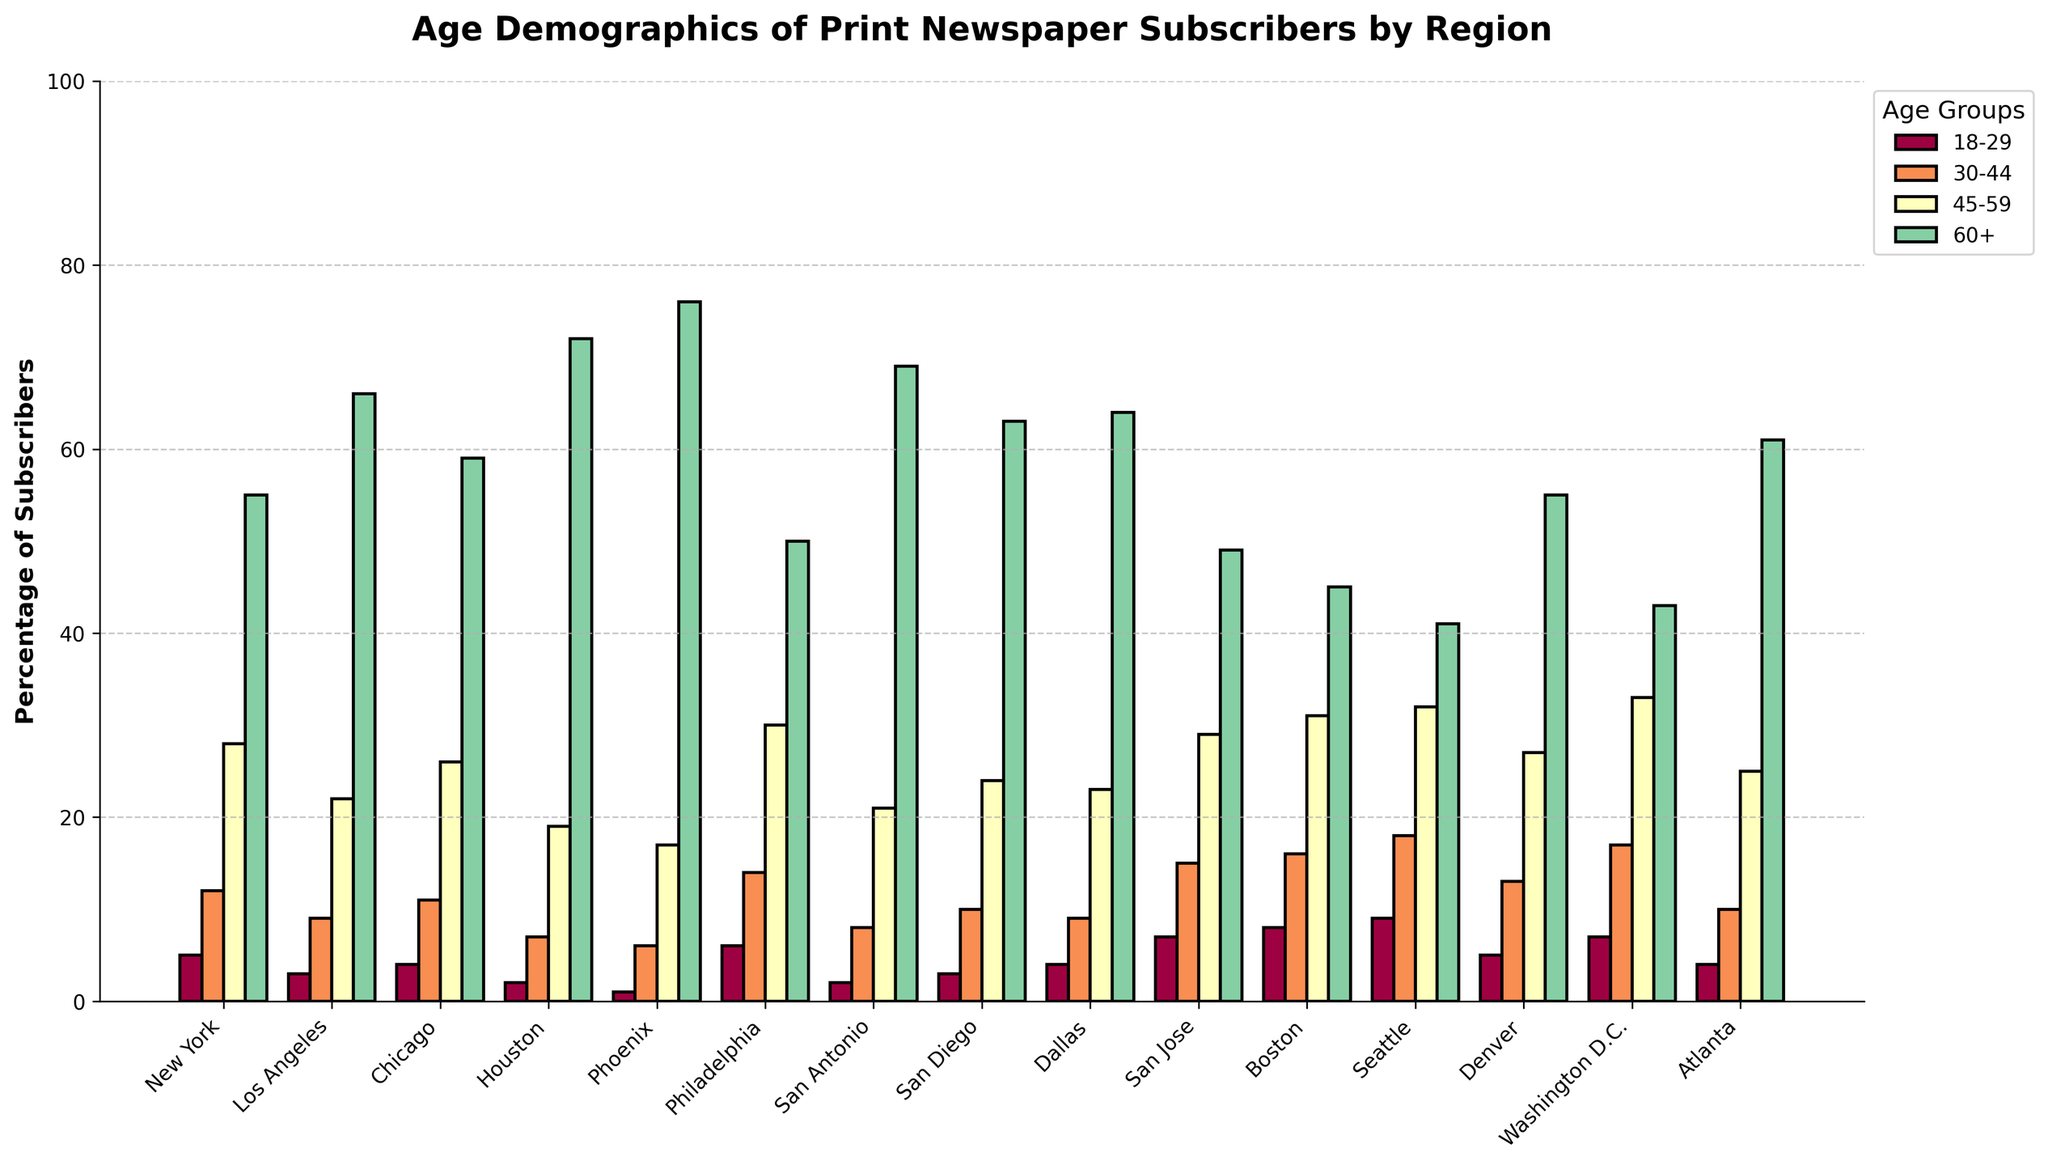Which region has the highest percentage of subscribers aged 60+? By examining the bar heights, Phoenix has the tallest bar for the 60+ age group, indicating the highest percentage.
Answer: Phoenix Which region has the lowest percentage of subscribers aged 18-29? The bar for Phoenix in the 18-29 age group is the shortest compared to all other regions.
Answer: Phoenix What is the sum of the percentage of subscribers aged 30-44 and 45-59 in Chicago? For Chicago, the 30-44 age group is 11% and the 45-59 age group is 26%. Summing these percentages: 11 + 26 = 37.
Answer: 37 Which age group has the most consistent percentage across the regions? By visually comparing the bar heights, the 60+ age group shows less variability across different regions compared to the other age groups.
Answer: 60+ In which region is the percentage difference between the 18-29 and 60+ age groups the greatest? The largest difference in bar height between the 18-29 and 60+ age groups appears in Phoenix, where the difference is 76 - 1 = 75.
Answer: Phoenix 